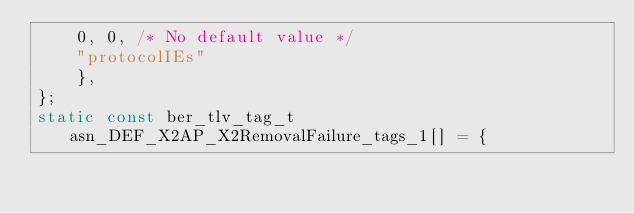<code> <loc_0><loc_0><loc_500><loc_500><_C_>		0, 0, /* No default value */
		"protocolIEs"
		},
};
static const ber_tlv_tag_t asn_DEF_X2AP_X2RemovalFailure_tags_1[] = {</code> 